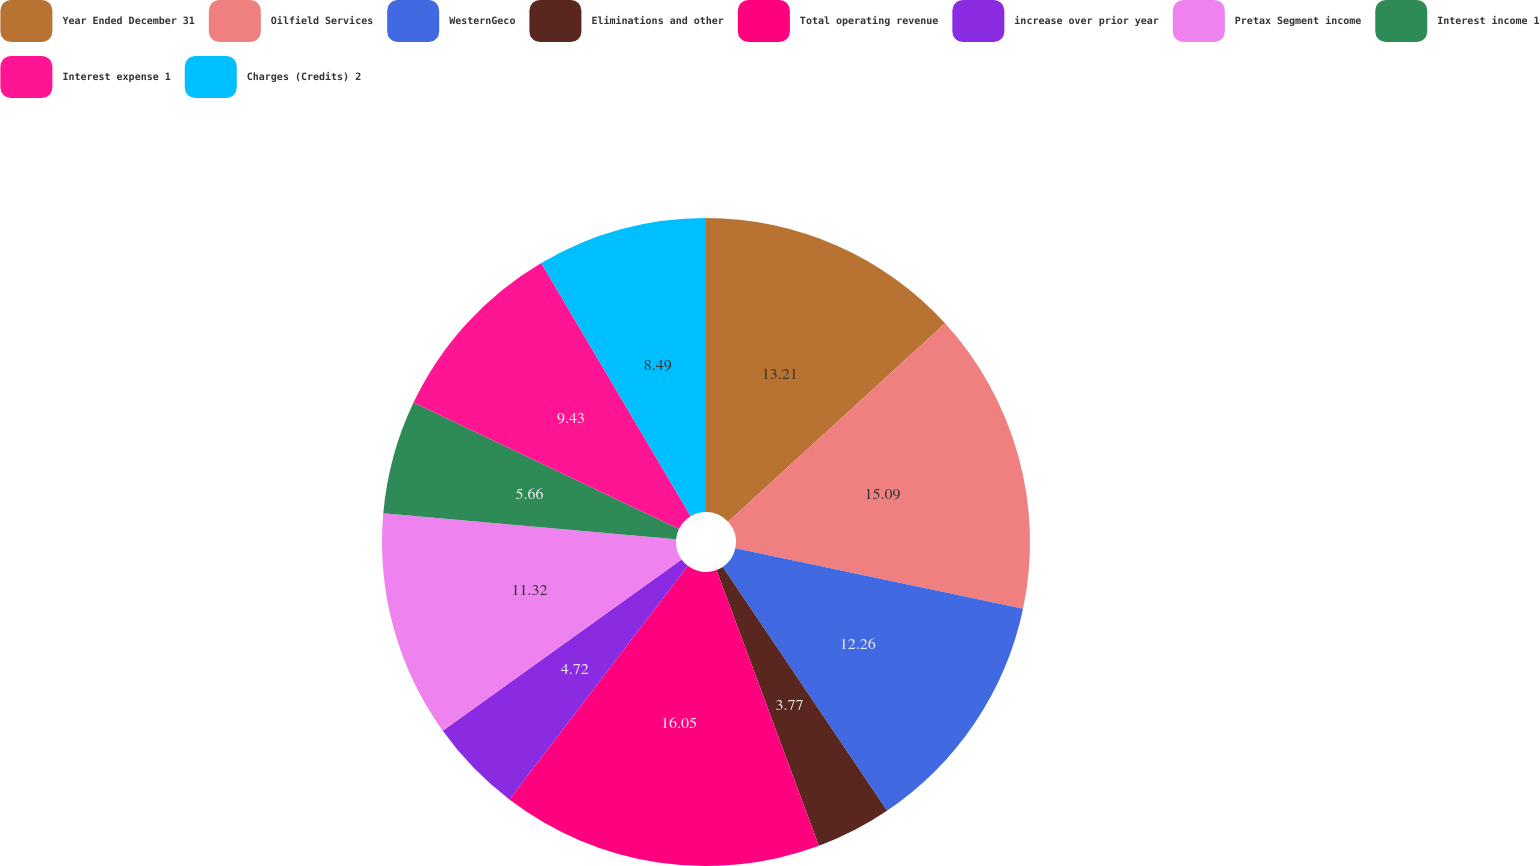Convert chart to OTSL. <chart><loc_0><loc_0><loc_500><loc_500><pie_chart><fcel>Year Ended December 31<fcel>Oilfield Services<fcel>WesternGeco<fcel>Eliminations and other<fcel>Total operating revenue<fcel>increase over prior year<fcel>Pretax Segment income<fcel>Interest income 1<fcel>Interest expense 1<fcel>Charges (Credits) 2<nl><fcel>13.21%<fcel>15.09%<fcel>12.26%<fcel>3.77%<fcel>16.04%<fcel>4.72%<fcel>11.32%<fcel>5.66%<fcel>9.43%<fcel>8.49%<nl></chart> 